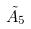Convert formula to latex. <formula><loc_0><loc_0><loc_500><loc_500>\tilde { A } _ { 5 }</formula> 